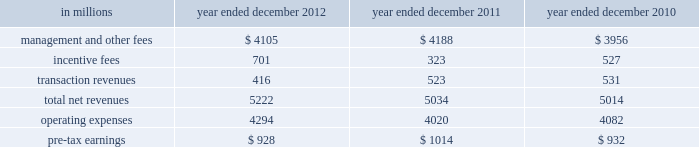Management 2019s discussion and analysis 2011 versus 2010 .
Net revenues in investing & lending were $ 2.14 billion and $ 7.54 billion for 2011 and 2010 , respectively .
During 2011 , investing & lending results reflected an operating environment characterized by a significant decline in equity markets in europe and asia , and unfavorable credit markets that were negatively impacted by increased concerns regarding the weakened state of global economies , including heightened european sovereign debt risk .
Results for 2011 included a loss of $ 517 million from our investment in the ordinary shares of icbc and net gains of $ 1.12 billion from other investments in equities , primarily in private equities , partially offset by losses from public equities .
In addition , investing & lending included net revenues of $ 96 million from debt securities and loans .
This amount includes approximately $ 1 billion of unrealized losses related to relationship lending activities , including the effect of hedges , offset by net interest income and net gains from other debt securities and loans .
Results for 2011 also included other net revenues of $ 1.44 billion , principally related to our consolidated investment entities .
Results for 2010 included a gain of $ 747 million from our investment in the ordinary shares of icbc , a net gain of $ 2.69 billion from other investments in equities , a net gain of $ 2.60 billion from debt securities and loans and other net revenues of $ 1.51 billion , principally related to our consolidated investment entities .
The net gain from other investments in equities was primarily driven by an increase in global equity markets , which resulted in appreciation of both our public and private equity positions and provided favorable conditions for initial public offerings .
The net gains and net interest from debt securities and loans primarily reflected the impact of tighter credit spreads and favorable credit markets during the year , which provided favorable conditions for borrowers to refinance .
Operating expenses were $ 2.67 billion for 2011 , 20% ( 20 % ) lower than 2010 , due to decreased compensation and benefits expenses , primarily resulting from lower net revenues .
This decrease was partially offset by the impact of impairment charges related to consolidated investments during 2011 .
Pre-tax loss was $ 531 million in 2011 , compared with pre-tax earnings of $ 4.18 billion in 2010 .
Investment management investment management provides investment management services and offers investment products ( primarily through separately managed accounts and commingled vehicles , such as mutual funds and private investment funds ) across all major asset classes to a diverse set of institutional and individual clients .
Investment management also offers wealth advisory services , including portfolio management and financial counseling , and brokerage and other transaction services to high-net-worth individuals and families .
Assets under supervision include assets under management and other client assets .
Assets under management include client assets where we earn a fee for managing assets on a discretionary basis .
This includes net assets in our mutual funds , hedge funds , credit funds and private equity funds ( including real estate funds ) , and separately managed accounts for institutional and individual investors .
Other client assets include client assets invested with third-party managers , private bank deposits and assets related to advisory relationships where we earn a fee for advisory and other services , but do not have discretion over the assets .
Assets under supervision do not include the self-directed brokerage accounts of our clients .
Assets under management and other client assets typically generate fees as a percentage of net asset value , which vary by asset class and are affected by investment performance as well as asset inflows and redemptions .
In certain circumstances , we are also entitled to receive incentive fees based on a percentage of a fund 2019s return or when the return exceeds a specified benchmark or other performance targets .
Incentive fees are recognized only when all material contingencies are resolved .
The table below presents the operating results of our investment management segment. .
56 goldman sachs 2012 annual report .
What were average incentive fees in millions for the three year period? 
Computations: table_average(incentive fees, none)
Answer: 517.0. Management 2019s discussion and analysis 2011 versus 2010 .
Net revenues in investing & lending were $ 2.14 billion and $ 7.54 billion for 2011 and 2010 , respectively .
During 2011 , investing & lending results reflected an operating environment characterized by a significant decline in equity markets in europe and asia , and unfavorable credit markets that were negatively impacted by increased concerns regarding the weakened state of global economies , including heightened european sovereign debt risk .
Results for 2011 included a loss of $ 517 million from our investment in the ordinary shares of icbc and net gains of $ 1.12 billion from other investments in equities , primarily in private equities , partially offset by losses from public equities .
In addition , investing & lending included net revenues of $ 96 million from debt securities and loans .
This amount includes approximately $ 1 billion of unrealized losses related to relationship lending activities , including the effect of hedges , offset by net interest income and net gains from other debt securities and loans .
Results for 2011 also included other net revenues of $ 1.44 billion , principally related to our consolidated investment entities .
Results for 2010 included a gain of $ 747 million from our investment in the ordinary shares of icbc , a net gain of $ 2.69 billion from other investments in equities , a net gain of $ 2.60 billion from debt securities and loans and other net revenues of $ 1.51 billion , principally related to our consolidated investment entities .
The net gain from other investments in equities was primarily driven by an increase in global equity markets , which resulted in appreciation of both our public and private equity positions and provided favorable conditions for initial public offerings .
The net gains and net interest from debt securities and loans primarily reflected the impact of tighter credit spreads and favorable credit markets during the year , which provided favorable conditions for borrowers to refinance .
Operating expenses were $ 2.67 billion for 2011 , 20% ( 20 % ) lower than 2010 , due to decreased compensation and benefits expenses , primarily resulting from lower net revenues .
This decrease was partially offset by the impact of impairment charges related to consolidated investments during 2011 .
Pre-tax loss was $ 531 million in 2011 , compared with pre-tax earnings of $ 4.18 billion in 2010 .
Investment management investment management provides investment management services and offers investment products ( primarily through separately managed accounts and commingled vehicles , such as mutual funds and private investment funds ) across all major asset classes to a diverse set of institutional and individual clients .
Investment management also offers wealth advisory services , including portfolio management and financial counseling , and brokerage and other transaction services to high-net-worth individuals and families .
Assets under supervision include assets under management and other client assets .
Assets under management include client assets where we earn a fee for managing assets on a discretionary basis .
This includes net assets in our mutual funds , hedge funds , credit funds and private equity funds ( including real estate funds ) , and separately managed accounts for institutional and individual investors .
Other client assets include client assets invested with third-party managers , private bank deposits and assets related to advisory relationships where we earn a fee for advisory and other services , but do not have discretion over the assets .
Assets under supervision do not include the self-directed brokerage accounts of our clients .
Assets under management and other client assets typically generate fees as a percentage of net asset value , which vary by asset class and are affected by investment performance as well as asset inflows and redemptions .
In certain circumstances , we are also entitled to receive incentive fees based on a percentage of a fund 2019s return or when the return exceeds a specified benchmark or other performance targets .
Incentive fees are recognized only when all material contingencies are resolved .
The table below presents the operating results of our investment management segment. .
56 goldman sachs 2012 annual report .
For the investment management segment , what was the change in pre-tax earnings between 2012 and 2011 , in millions? 
Computations: (1014 - 928)
Answer: 86.0. 